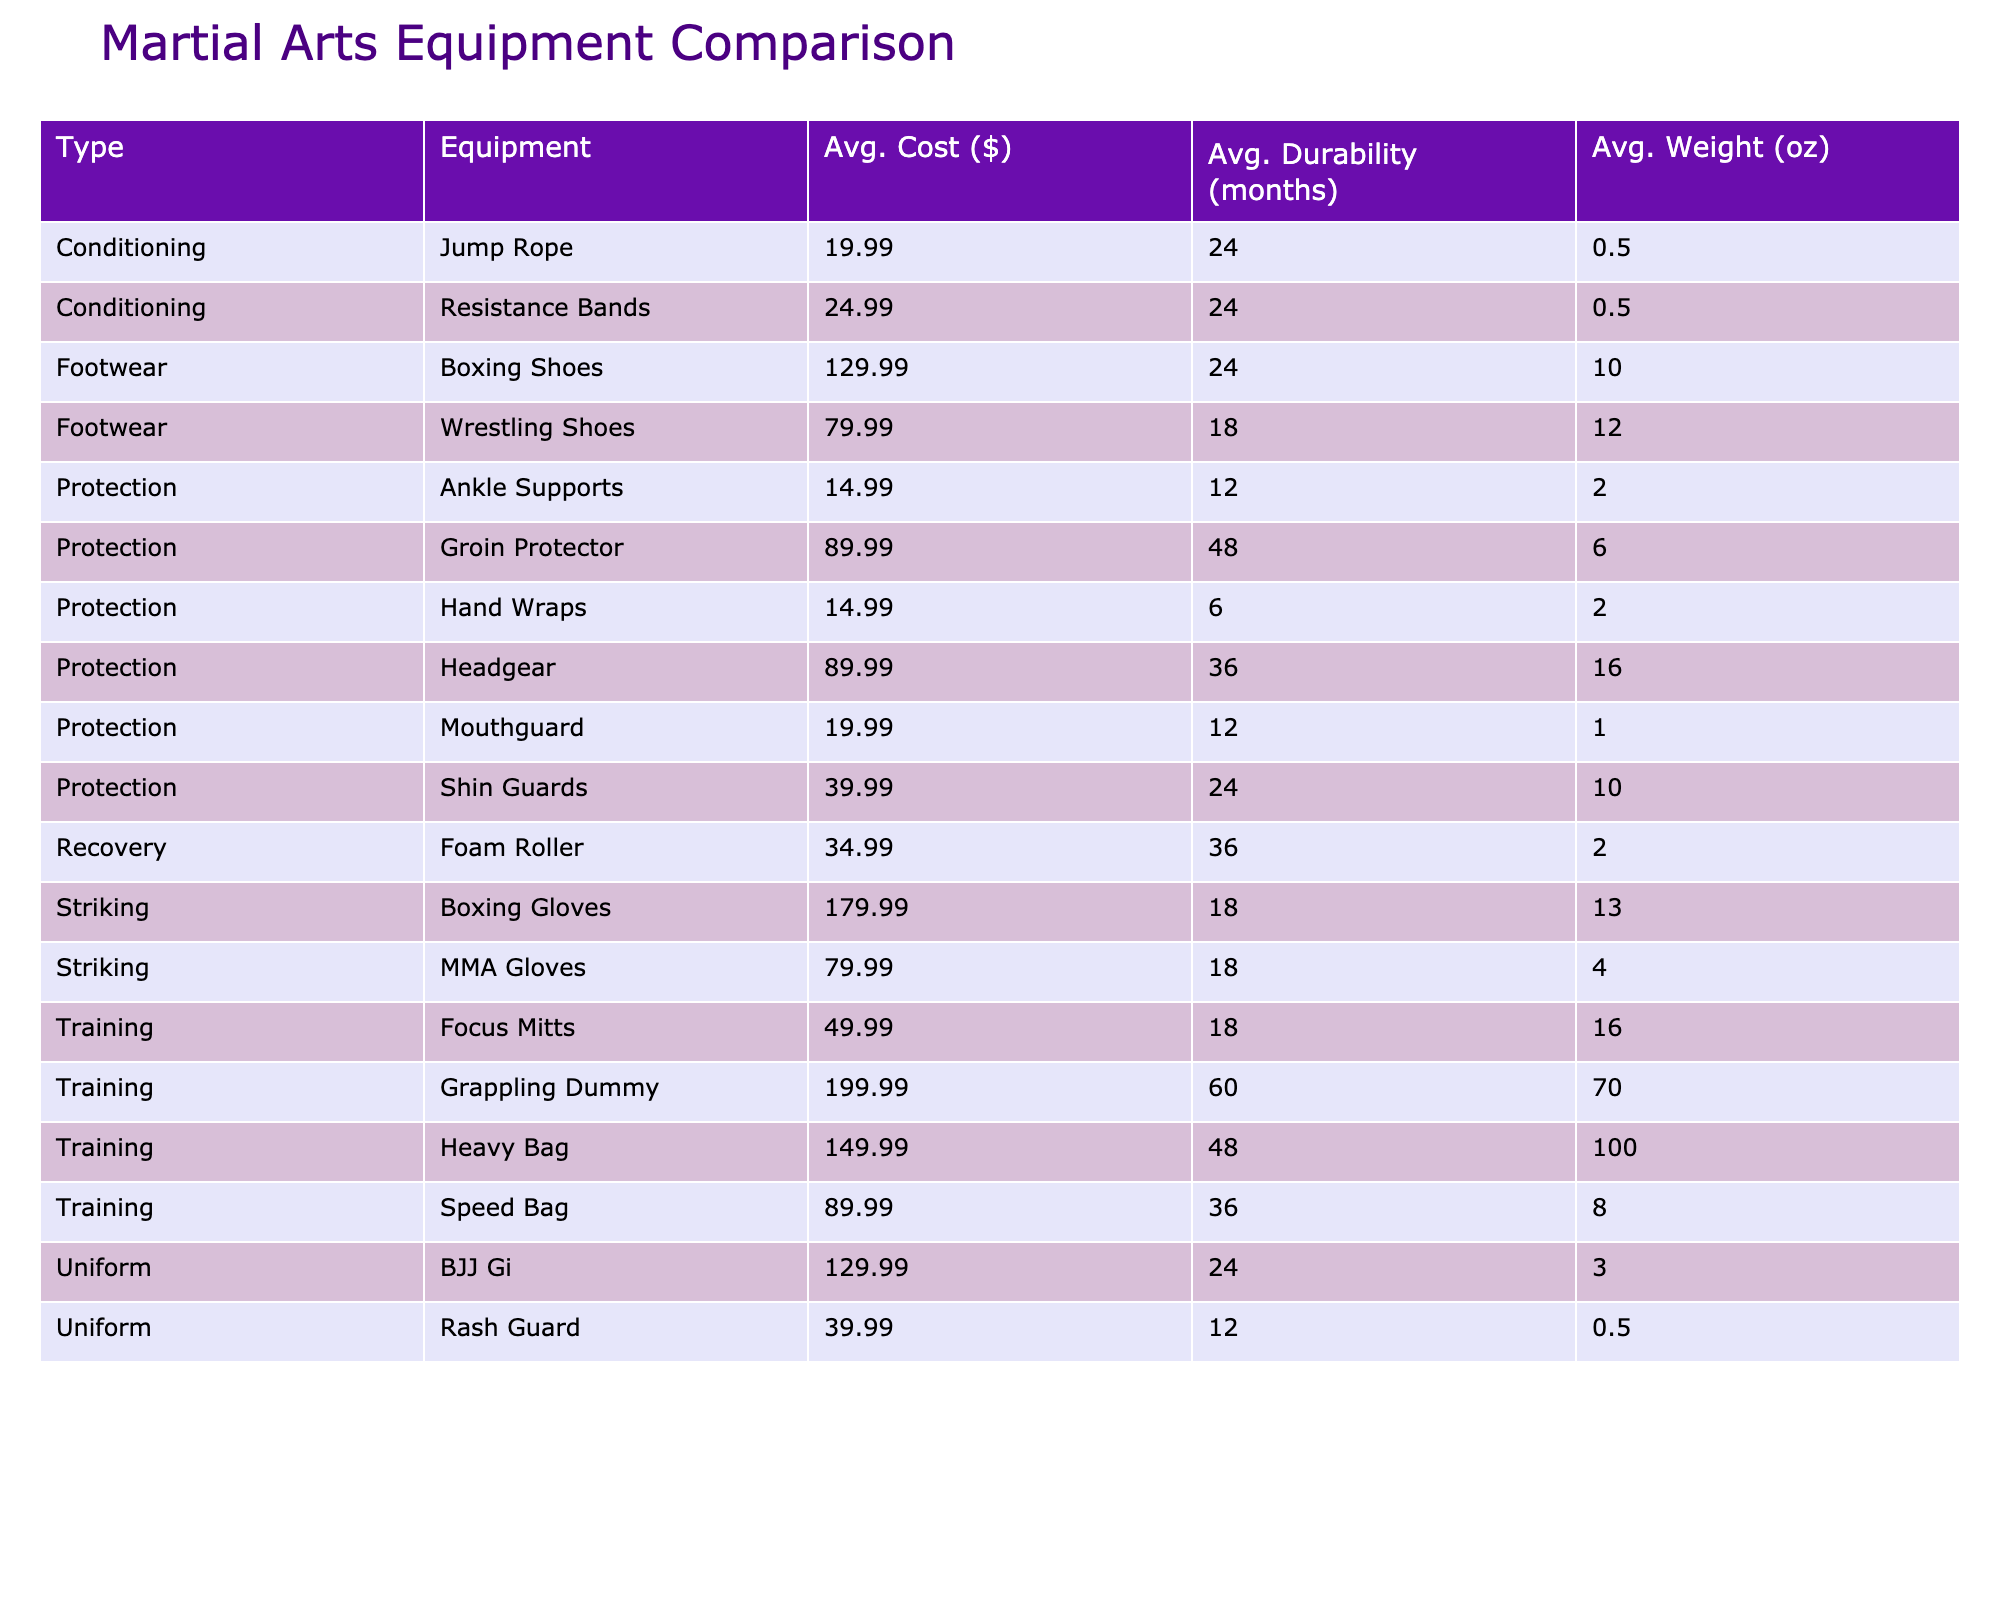What is the average cost of headgear? The headgear is listed in the table with a cost of $89.99. Since there is only one headgear entry, that price is also the average cost.
Answer: 89.99 Which equipment type has the highest average durability? Looking at the durability values, the grappling dummy has 60 months, which is the highest compared to any other equipment.
Answer: 60 Are all boxing shoes recommended for beginners? The table shows two types of boxing shoes. Both entries specify 'No' under the "Recommended for Beginners" column.
Answer: No What is the average weight of MMA gloves? There is one entry for MMA gloves weighing 4 ounces. Since there are no other entries to average with, the average weight is just this value.
Answer: 4 How much does it cost on average for protection equipment? The cost of protection equipment entries are $14.99, $89.99, $19.99, $39.99, $89.99, and $14.99. Summing them gives $14.99 + $89.99 + $19.99 + $39.99 + $89.99 + $14.99 = $269.94. The average cost is $269.94 divided by 6, which equals approximately $44.99.
Answer: 44.99 How many protections are recommended for beginners? The table lists 5 types of equipment that are marked 'Yes' in the "Recommended for Beginners" column: hand wraps, headgear, shin guards, mouthguard, and ankle supports. Count these entries gives a total of 5.
Answer: 5 What is the difference in average cost between striking and training equipment? The average cost for striking equipment is $79.99 (Boxing gloves: $59.99 + $299.99 + MMA gloves: $79.99) / 3 = $146.99. The average cost for training equipment is $149.99 (Heavy Bag: $149.99 + Focus Mitts: $49.99 + Speed Bag: $89.99) / 3 = $96.99. The difference is $146.99 - $96.99 = $50.00.
Answer: 50.00 What equipment has the lowest weight among all listed? Referring to the weight values, the jump rope weighs only 0.5 ounces, which is the lowest among all the entries.
Answer: 0.5 What is the total durability of all uniform types of equipment combined? The BJJ Gi has 24 months and the Rash Guard has 12 months. Summing these gives us a total durability of 24 + 12 = 36 months for uniform types.
Answer: 36 